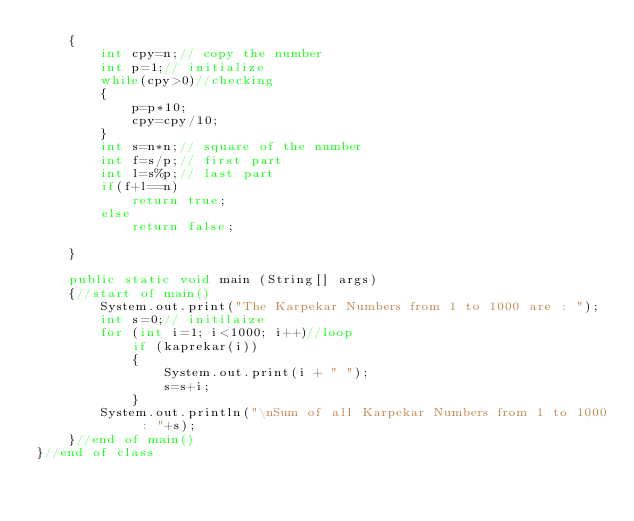Convert code to text. <code><loc_0><loc_0><loc_500><loc_500><_Java_>    {   
        int cpy=n;// copy the number
        int p=1;// initialize
        while(cpy>0)//checking
        {
            p=p*10;
            cpy=cpy/10;
        }
        int s=n*n;// square of the number
        int f=s/p;// first part
        int l=s%p;// last part
        if(f+l==n)
            return true;
        else
            return false;

    }   

    public static void main (String[] args)   
    {//start of main()   
        System.out.print("The Karpekar Numbers from 1 to 1000 are : ");
        int s=0;// initilaize
        for (int i=1; i<1000; i++)//loop   
            if (kaprekar(i))   
            {
                System.out.print(i + " ");  
                s=s+i;
            }
        System.out.println("\nSum of all Karpekar Numbers from 1 to 1000 : "+s);
    }//end of main()
}//end of class      </code> 